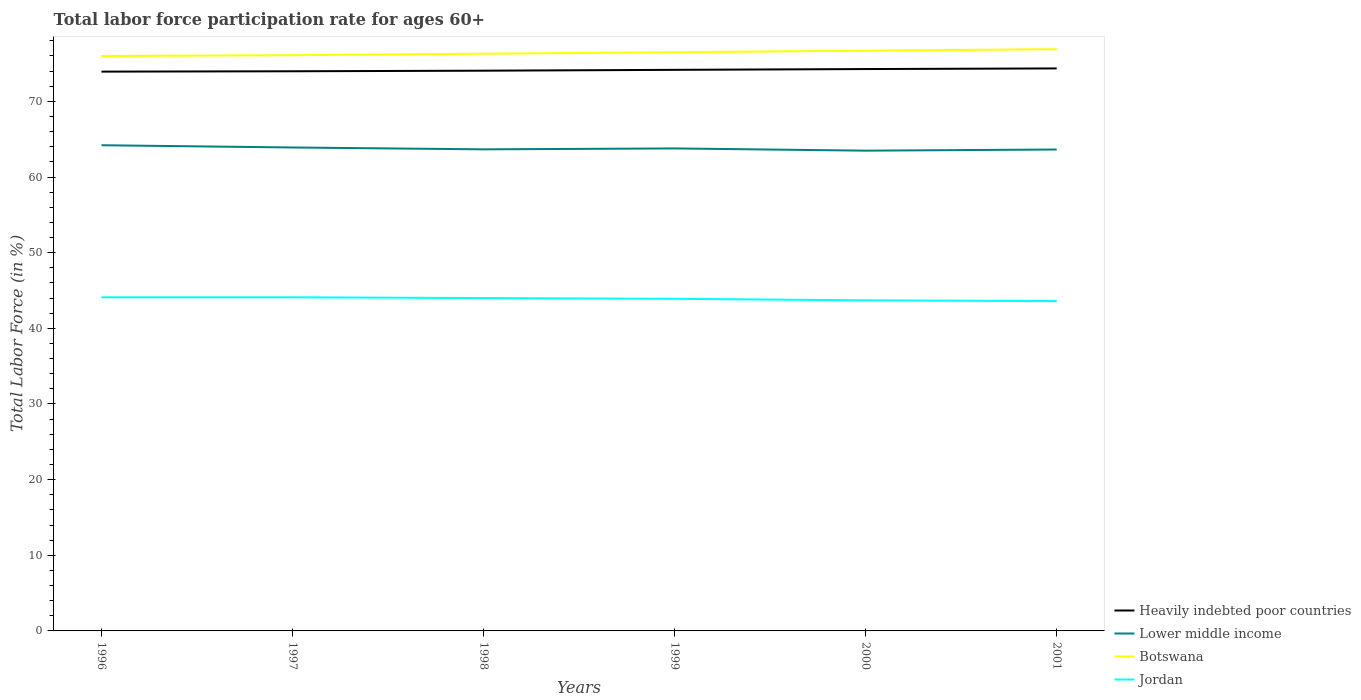How many different coloured lines are there?
Offer a terse response. 4. Across all years, what is the maximum labor force participation rate in Heavily indebted poor countries?
Offer a terse response. 73.93. In which year was the labor force participation rate in Botswana maximum?
Offer a very short reply. 1996. What is the total labor force participation rate in Lower middle income in the graph?
Ensure brevity in your answer.  0.25. How many lines are there?
Make the answer very short. 4. What is the difference between two consecutive major ticks on the Y-axis?
Your response must be concise. 10. Are the values on the major ticks of Y-axis written in scientific E-notation?
Provide a short and direct response. No. Does the graph contain grids?
Give a very brief answer. No. What is the title of the graph?
Your response must be concise. Total labor force participation rate for ages 60+. Does "Sub-Saharan Africa (all income levels)" appear as one of the legend labels in the graph?
Provide a succinct answer. No. What is the label or title of the Y-axis?
Provide a succinct answer. Total Labor Force (in %). What is the Total Labor Force (in %) in Heavily indebted poor countries in 1996?
Your answer should be very brief. 73.93. What is the Total Labor Force (in %) in Lower middle income in 1996?
Your response must be concise. 64.2. What is the Total Labor Force (in %) of Botswana in 1996?
Offer a terse response. 76. What is the Total Labor Force (in %) in Jordan in 1996?
Keep it short and to the point. 44.1. What is the Total Labor Force (in %) in Heavily indebted poor countries in 1997?
Provide a succinct answer. 73.98. What is the Total Labor Force (in %) of Lower middle income in 1997?
Your response must be concise. 63.9. What is the Total Labor Force (in %) of Botswana in 1997?
Ensure brevity in your answer.  76.1. What is the Total Labor Force (in %) in Jordan in 1997?
Ensure brevity in your answer.  44.1. What is the Total Labor Force (in %) of Heavily indebted poor countries in 1998?
Provide a short and direct response. 74.06. What is the Total Labor Force (in %) in Lower middle income in 1998?
Provide a short and direct response. 63.66. What is the Total Labor Force (in %) of Botswana in 1998?
Keep it short and to the point. 76.3. What is the Total Labor Force (in %) of Heavily indebted poor countries in 1999?
Provide a short and direct response. 74.17. What is the Total Labor Force (in %) in Lower middle income in 1999?
Your answer should be compact. 63.78. What is the Total Labor Force (in %) of Botswana in 1999?
Provide a short and direct response. 76.5. What is the Total Labor Force (in %) in Jordan in 1999?
Your answer should be very brief. 43.9. What is the Total Labor Force (in %) in Heavily indebted poor countries in 2000?
Offer a terse response. 74.27. What is the Total Labor Force (in %) of Lower middle income in 2000?
Provide a short and direct response. 63.49. What is the Total Labor Force (in %) in Botswana in 2000?
Provide a short and direct response. 76.7. What is the Total Labor Force (in %) in Jordan in 2000?
Provide a short and direct response. 43.7. What is the Total Labor Force (in %) in Heavily indebted poor countries in 2001?
Your response must be concise. 74.36. What is the Total Labor Force (in %) of Lower middle income in 2001?
Keep it short and to the point. 63.64. What is the Total Labor Force (in %) of Botswana in 2001?
Make the answer very short. 76.9. What is the Total Labor Force (in %) in Jordan in 2001?
Provide a succinct answer. 43.6. Across all years, what is the maximum Total Labor Force (in %) of Heavily indebted poor countries?
Offer a terse response. 74.36. Across all years, what is the maximum Total Labor Force (in %) of Lower middle income?
Your answer should be very brief. 64.2. Across all years, what is the maximum Total Labor Force (in %) of Botswana?
Give a very brief answer. 76.9. Across all years, what is the maximum Total Labor Force (in %) in Jordan?
Your answer should be compact. 44.1. Across all years, what is the minimum Total Labor Force (in %) of Heavily indebted poor countries?
Your answer should be very brief. 73.93. Across all years, what is the minimum Total Labor Force (in %) of Lower middle income?
Your response must be concise. 63.49. Across all years, what is the minimum Total Labor Force (in %) of Botswana?
Your answer should be very brief. 76. Across all years, what is the minimum Total Labor Force (in %) of Jordan?
Keep it short and to the point. 43.6. What is the total Total Labor Force (in %) of Heavily indebted poor countries in the graph?
Provide a short and direct response. 444.76. What is the total Total Labor Force (in %) in Lower middle income in the graph?
Offer a very short reply. 382.67. What is the total Total Labor Force (in %) of Botswana in the graph?
Provide a short and direct response. 458.5. What is the total Total Labor Force (in %) in Jordan in the graph?
Your answer should be compact. 263.4. What is the difference between the Total Labor Force (in %) in Heavily indebted poor countries in 1996 and that in 1997?
Give a very brief answer. -0.05. What is the difference between the Total Labor Force (in %) of Lower middle income in 1996 and that in 1997?
Give a very brief answer. 0.3. What is the difference between the Total Labor Force (in %) of Heavily indebted poor countries in 1996 and that in 1998?
Provide a short and direct response. -0.12. What is the difference between the Total Labor Force (in %) of Lower middle income in 1996 and that in 1998?
Keep it short and to the point. 0.55. What is the difference between the Total Labor Force (in %) in Botswana in 1996 and that in 1998?
Give a very brief answer. -0.3. What is the difference between the Total Labor Force (in %) of Jordan in 1996 and that in 1998?
Make the answer very short. 0.1. What is the difference between the Total Labor Force (in %) in Heavily indebted poor countries in 1996 and that in 1999?
Your answer should be very brief. -0.24. What is the difference between the Total Labor Force (in %) of Lower middle income in 1996 and that in 1999?
Make the answer very short. 0.42. What is the difference between the Total Labor Force (in %) of Jordan in 1996 and that in 1999?
Your answer should be very brief. 0.2. What is the difference between the Total Labor Force (in %) of Heavily indebted poor countries in 1996 and that in 2000?
Keep it short and to the point. -0.34. What is the difference between the Total Labor Force (in %) of Lower middle income in 1996 and that in 2000?
Offer a very short reply. 0.72. What is the difference between the Total Labor Force (in %) of Botswana in 1996 and that in 2000?
Your answer should be very brief. -0.7. What is the difference between the Total Labor Force (in %) in Heavily indebted poor countries in 1996 and that in 2001?
Provide a succinct answer. -0.43. What is the difference between the Total Labor Force (in %) of Lower middle income in 1996 and that in 2001?
Give a very brief answer. 0.57. What is the difference between the Total Labor Force (in %) in Botswana in 1996 and that in 2001?
Your answer should be compact. -0.9. What is the difference between the Total Labor Force (in %) of Jordan in 1996 and that in 2001?
Give a very brief answer. 0.5. What is the difference between the Total Labor Force (in %) of Heavily indebted poor countries in 1997 and that in 1998?
Ensure brevity in your answer.  -0.07. What is the difference between the Total Labor Force (in %) in Lower middle income in 1997 and that in 1998?
Your response must be concise. 0.25. What is the difference between the Total Labor Force (in %) of Botswana in 1997 and that in 1998?
Your response must be concise. -0.2. What is the difference between the Total Labor Force (in %) of Heavily indebted poor countries in 1997 and that in 1999?
Offer a very short reply. -0.19. What is the difference between the Total Labor Force (in %) of Lower middle income in 1997 and that in 1999?
Provide a succinct answer. 0.12. What is the difference between the Total Labor Force (in %) of Botswana in 1997 and that in 1999?
Provide a succinct answer. -0.4. What is the difference between the Total Labor Force (in %) in Heavily indebted poor countries in 1997 and that in 2000?
Your answer should be compact. -0.29. What is the difference between the Total Labor Force (in %) of Lower middle income in 1997 and that in 2000?
Provide a succinct answer. 0.42. What is the difference between the Total Labor Force (in %) in Botswana in 1997 and that in 2000?
Ensure brevity in your answer.  -0.6. What is the difference between the Total Labor Force (in %) of Jordan in 1997 and that in 2000?
Give a very brief answer. 0.4. What is the difference between the Total Labor Force (in %) of Heavily indebted poor countries in 1997 and that in 2001?
Ensure brevity in your answer.  -0.38. What is the difference between the Total Labor Force (in %) in Lower middle income in 1997 and that in 2001?
Your answer should be compact. 0.27. What is the difference between the Total Labor Force (in %) in Botswana in 1997 and that in 2001?
Give a very brief answer. -0.8. What is the difference between the Total Labor Force (in %) in Jordan in 1997 and that in 2001?
Offer a very short reply. 0.5. What is the difference between the Total Labor Force (in %) of Heavily indebted poor countries in 1998 and that in 1999?
Ensure brevity in your answer.  -0.11. What is the difference between the Total Labor Force (in %) in Lower middle income in 1998 and that in 1999?
Offer a terse response. -0.12. What is the difference between the Total Labor Force (in %) of Heavily indebted poor countries in 1998 and that in 2000?
Provide a succinct answer. -0.22. What is the difference between the Total Labor Force (in %) in Lower middle income in 1998 and that in 2000?
Offer a very short reply. 0.17. What is the difference between the Total Labor Force (in %) in Jordan in 1998 and that in 2000?
Make the answer very short. 0.3. What is the difference between the Total Labor Force (in %) of Heavily indebted poor countries in 1998 and that in 2001?
Your answer should be very brief. -0.3. What is the difference between the Total Labor Force (in %) in Lower middle income in 1998 and that in 2001?
Keep it short and to the point. 0.02. What is the difference between the Total Labor Force (in %) of Botswana in 1998 and that in 2001?
Your answer should be compact. -0.6. What is the difference between the Total Labor Force (in %) of Jordan in 1998 and that in 2001?
Ensure brevity in your answer.  0.4. What is the difference between the Total Labor Force (in %) in Heavily indebted poor countries in 1999 and that in 2000?
Your response must be concise. -0.11. What is the difference between the Total Labor Force (in %) of Lower middle income in 1999 and that in 2000?
Ensure brevity in your answer.  0.3. What is the difference between the Total Labor Force (in %) in Botswana in 1999 and that in 2000?
Your answer should be compact. -0.2. What is the difference between the Total Labor Force (in %) in Jordan in 1999 and that in 2000?
Provide a succinct answer. 0.2. What is the difference between the Total Labor Force (in %) of Heavily indebted poor countries in 1999 and that in 2001?
Your answer should be compact. -0.19. What is the difference between the Total Labor Force (in %) of Lower middle income in 1999 and that in 2001?
Make the answer very short. 0.14. What is the difference between the Total Labor Force (in %) of Jordan in 1999 and that in 2001?
Keep it short and to the point. 0.3. What is the difference between the Total Labor Force (in %) of Heavily indebted poor countries in 2000 and that in 2001?
Give a very brief answer. -0.08. What is the difference between the Total Labor Force (in %) in Lower middle income in 2000 and that in 2001?
Offer a very short reply. -0.15. What is the difference between the Total Labor Force (in %) of Botswana in 2000 and that in 2001?
Keep it short and to the point. -0.2. What is the difference between the Total Labor Force (in %) in Heavily indebted poor countries in 1996 and the Total Labor Force (in %) in Lower middle income in 1997?
Offer a terse response. 10.03. What is the difference between the Total Labor Force (in %) of Heavily indebted poor countries in 1996 and the Total Labor Force (in %) of Botswana in 1997?
Make the answer very short. -2.17. What is the difference between the Total Labor Force (in %) in Heavily indebted poor countries in 1996 and the Total Labor Force (in %) in Jordan in 1997?
Offer a very short reply. 29.83. What is the difference between the Total Labor Force (in %) of Lower middle income in 1996 and the Total Labor Force (in %) of Botswana in 1997?
Offer a very short reply. -11.9. What is the difference between the Total Labor Force (in %) of Lower middle income in 1996 and the Total Labor Force (in %) of Jordan in 1997?
Offer a terse response. 20.1. What is the difference between the Total Labor Force (in %) in Botswana in 1996 and the Total Labor Force (in %) in Jordan in 1997?
Provide a succinct answer. 31.9. What is the difference between the Total Labor Force (in %) of Heavily indebted poor countries in 1996 and the Total Labor Force (in %) of Lower middle income in 1998?
Keep it short and to the point. 10.27. What is the difference between the Total Labor Force (in %) of Heavily indebted poor countries in 1996 and the Total Labor Force (in %) of Botswana in 1998?
Ensure brevity in your answer.  -2.37. What is the difference between the Total Labor Force (in %) of Heavily indebted poor countries in 1996 and the Total Labor Force (in %) of Jordan in 1998?
Keep it short and to the point. 29.93. What is the difference between the Total Labor Force (in %) in Lower middle income in 1996 and the Total Labor Force (in %) in Botswana in 1998?
Give a very brief answer. -12.1. What is the difference between the Total Labor Force (in %) in Lower middle income in 1996 and the Total Labor Force (in %) in Jordan in 1998?
Give a very brief answer. 20.2. What is the difference between the Total Labor Force (in %) of Botswana in 1996 and the Total Labor Force (in %) of Jordan in 1998?
Provide a short and direct response. 32. What is the difference between the Total Labor Force (in %) in Heavily indebted poor countries in 1996 and the Total Labor Force (in %) in Lower middle income in 1999?
Provide a succinct answer. 10.15. What is the difference between the Total Labor Force (in %) of Heavily indebted poor countries in 1996 and the Total Labor Force (in %) of Botswana in 1999?
Keep it short and to the point. -2.57. What is the difference between the Total Labor Force (in %) in Heavily indebted poor countries in 1996 and the Total Labor Force (in %) in Jordan in 1999?
Ensure brevity in your answer.  30.03. What is the difference between the Total Labor Force (in %) in Lower middle income in 1996 and the Total Labor Force (in %) in Botswana in 1999?
Your answer should be very brief. -12.3. What is the difference between the Total Labor Force (in %) of Lower middle income in 1996 and the Total Labor Force (in %) of Jordan in 1999?
Your response must be concise. 20.3. What is the difference between the Total Labor Force (in %) of Botswana in 1996 and the Total Labor Force (in %) of Jordan in 1999?
Your answer should be compact. 32.1. What is the difference between the Total Labor Force (in %) in Heavily indebted poor countries in 1996 and the Total Labor Force (in %) in Lower middle income in 2000?
Offer a terse response. 10.45. What is the difference between the Total Labor Force (in %) of Heavily indebted poor countries in 1996 and the Total Labor Force (in %) of Botswana in 2000?
Offer a very short reply. -2.77. What is the difference between the Total Labor Force (in %) in Heavily indebted poor countries in 1996 and the Total Labor Force (in %) in Jordan in 2000?
Your response must be concise. 30.23. What is the difference between the Total Labor Force (in %) in Lower middle income in 1996 and the Total Labor Force (in %) in Botswana in 2000?
Your response must be concise. -12.5. What is the difference between the Total Labor Force (in %) in Lower middle income in 1996 and the Total Labor Force (in %) in Jordan in 2000?
Your answer should be compact. 20.5. What is the difference between the Total Labor Force (in %) in Botswana in 1996 and the Total Labor Force (in %) in Jordan in 2000?
Offer a terse response. 32.3. What is the difference between the Total Labor Force (in %) in Heavily indebted poor countries in 1996 and the Total Labor Force (in %) in Lower middle income in 2001?
Provide a succinct answer. 10.29. What is the difference between the Total Labor Force (in %) of Heavily indebted poor countries in 1996 and the Total Labor Force (in %) of Botswana in 2001?
Offer a terse response. -2.97. What is the difference between the Total Labor Force (in %) in Heavily indebted poor countries in 1996 and the Total Labor Force (in %) in Jordan in 2001?
Your answer should be very brief. 30.33. What is the difference between the Total Labor Force (in %) in Lower middle income in 1996 and the Total Labor Force (in %) in Botswana in 2001?
Offer a very short reply. -12.7. What is the difference between the Total Labor Force (in %) of Lower middle income in 1996 and the Total Labor Force (in %) of Jordan in 2001?
Your response must be concise. 20.6. What is the difference between the Total Labor Force (in %) of Botswana in 1996 and the Total Labor Force (in %) of Jordan in 2001?
Offer a very short reply. 32.4. What is the difference between the Total Labor Force (in %) of Heavily indebted poor countries in 1997 and the Total Labor Force (in %) of Lower middle income in 1998?
Your answer should be compact. 10.32. What is the difference between the Total Labor Force (in %) in Heavily indebted poor countries in 1997 and the Total Labor Force (in %) in Botswana in 1998?
Your response must be concise. -2.32. What is the difference between the Total Labor Force (in %) of Heavily indebted poor countries in 1997 and the Total Labor Force (in %) of Jordan in 1998?
Your answer should be very brief. 29.98. What is the difference between the Total Labor Force (in %) in Lower middle income in 1997 and the Total Labor Force (in %) in Botswana in 1998?
Offer a very short reply. -12.4. What is the difference between the Total Labor Force (in %) in Lower middle income in 1997 and the Total Labor Force (in %) in Jordan in 1998?
Ensure brevity in your answer.  19.9. What is the difference between the Total Labor Force (in %) of Botswana in 1997 and the Total Labor Force (in %) of Jordan in 1998?
Your answer should be compact. 32.1. What is the difference between the Total Labor Force (in %) of Heavily indebted poor countries in 1997 and the Total Labor Force (in %) of Lower middle income in 1999?
Offer a terse response. 10.2. What is the difference between the Total Labor Force (in %) of Heavily indebted poor countries in 1997 and the Total Labor Force (in %) of Botswana in 1999?
Provide a succinct answer. -2.52. What is the difference between the Total Labor Force (in %) in Heavily indebted poor countries in 1997 and the Total Labor Force (in %) in Jordan in 1999?
Ensure brevity in your answer.  30.08. What is the difference between the Total Labor Force (in %) in Lower middle income in 1997 and the Total Labor Force (in %) in Botswana in 1999?
Give a very brief answer. -12.6. What is the difference between the Total Labor Force (in %) of Lower middle income in 1997 and the Total Labor Force (in %) of Jordan in 1999?
Make the answer very short. 20. What is the difference between the Total Labor Force (in %) in Botswana in 1997 and the Total Labor Force (in %) in Jordan in 1999?
Make the answer very short. 32.2. What is the difference between the Total Labor Force (in %) of Heavily indebted poor countries in 1997 and the Total Labor Force (in %) of Lower middle income in 2000?
Your response must be concise. 10.49. What is the difference between the Total Labor Force (in %) in Heavily indebted poor countries in 1997 and the Total Labor Force (in %) in Botswana in 2000?
Ensure brevity in your answer.  -2.72. What is the difference between the Total Labor Force (in %) in Heavily indebted poor countries in 1997 and the Total Labor Force (in %) in Jordan in 2000?
Your answer should be very brief. 30.28. What is the difference between the Total Labor Force (in %) in Lower middle income in 1997 and the Total Labor Force (in %) in Botswana in 2000?
Offer a terse response. -12.8. What is the difference between the Total Labor Force (in %) in Lower middle income in 1997 and the Total Labor Force (in %) in Jordan in 2000?
Keep it short and to the point. 20.2. What is the difference between the Total Labor Force (in %) of Botswana in 1997 and the Total Labor Force (in %) of Jordan in 2000?
Your answer should be compact. 32.4. What is the difference between the Total Labor Force (in %) of Heavily indebted poor countries in 1997 and the Total Labor Force (in %) of Lower middle income in 2001?
Keep it short and to the point. 10.34. What is the difference between the Total Labor Force (in %) in Heavily indebted poor countries in 1997 and the Total Labor Force (in %) in Botswana in 2001?
Make the answer very short. -2.92. What is the difference between the Total Labor Force (in %) of Heavily indebted poor countries in 1997 and the Total Labor Force (in %) of Jordan in 2001?
Give a very brief answer. 30.38. What is the difference between the Total Labor Force (in %) in Lower middle income in 1997 and the Total Labor Force (in %) in Botswana in 2001?
Ensure brevity in your answer.  -13. What is the difference between the Total Labor Force (in %) of Lower middle income in 1997 and the Total Labor Force (in %) of Jordan in 2001?
Provide a short and direct response. 20.3. What is the difference between the Total Labor Force (in %) in Botswana in 1997 and the Total Labor Force (in %) in Jordan in 2001?
Keep it short and to the point. 32.5. What is the difference between the Total Labor Force (in %) in Heavily indebted poor countries in 1998 and the Total Labor Force (in %) in Lower middle income in 1999?
Give a very brief answer. 10.27. What is the difference between the Total Labor Force (in %) of Heavily indebted poor countries in 1998 and the Total Labor Force (in %) of Botswana in 1999?
Your answer should be compact. -2.44. What is the difference between the Total Labor Force (in %) of Heavily indebted poor countries in 1998 and the Total Labor Force (in %) of Jordan in 1999?
Give a very brief answer. 30.16. What is the difference between the Total Labor Force (in %) in Lower middle income in 1998 and the Total Labor Force (in %) in Botswana in 1999?
Your response must be concise. -12.84. What is the difference between the Total Labor Force (in %) of Lower middle income in 1998 and the Total Labor Force (in %) of Jordan in 1999?
Your answer should be very brief. 19.76. What is the difference between the Total Labor Force (in %) in Botswana in 1998 and the Total Labor Force (in %) in Jordan in 1999?
Make the answer very short. 32.4. What is the difference between the Total Labor Force (in %) in Heavily indebted poor countries in 1998 and the Total Labor Force (in %) in Lower middle income in 2000?
Make the answer very short. 10.57. What is the difference between the Total Labor Force (in %) of Heavily indebted poor countries in 1998 and the Total Labor Force (in %) of Botswana in 2000?
Provide a succinct answer. -2.64. What is the difference between the Total Labor Force (in %) in Heavily indebted poor countries in 1998 and the Total Labor Force (in %) in Jordan in 2000?
Your answer should be very brief. 30.36. What is the difference between the Total Labor Force (in %) in Lower middle income in 1998 and the Total Labor Force (in %) in Botswana in 2000?
Provide a short and direct response. -13.04. What is the difference between the Total Labor Force (in %) of Lower middle income in 1998 and the Total Labor Force (in %) of Jordan in 2000?
Offer a terse response. 19.96. What is the difference between the Total Labor Force (in %) of Botswana in 1998 and the Total Labor Force (in %) of Jordan in 2000?
Your answer should be very brief. 32.6. What is the difference between the Total Labor Force (in %) of Heavily indebted poor countries in 1998 and the Total Labor Force (in %) of Lower middle income in 2001?
Your response must be concise. 10.42. What is the difference between the Total Labor Force (in %) of Heavily indebted poor countries in 1998 and the Total Labor Force (in %) of Botswana in 2001?
Give a very brief answer. -2.84. What is the difference between the Total Labor Force (in %) of Heavily indebted poor countries in 1998 and the Total Labor Force (in %) of Jordan in 2001?
Provide a short and direct response. 30.46. What is the difference between the Total Labor Force (in %) of Lower middle income in 1998 and the Total Labor Force (in %) of Botswana in 2001?
Keep it short and to the point. -13.24. What is the difference between the Total Labor Force (in %) of Lower middle income in 1998 and the Total Labor Force (in %) of Jordan in 2001?
Keep it short and to the point. 20.06. What is the difference between the Total Labor Force (in %) in Botswana in 1998 and the Total Labor Force (in %) in Jordan in 2001?
Your answer should be compact. 32.7. What is the difference between the Total Labor Force (in %) in Heavily indebted poor countries in 1999 and the Total Labor Force (in %) in Lower middle income in 2000?
Give a very brief answer. 10.68. What is the difference between the Total Labor Force (in %) of Heavily indebted poor countries in 1999 and the Total Labor Force (in %) of Botswana in 2000?
Your answer should be very brief. -2.53. What is the difference between the Total Labor Force (in %) in Heavily indebted poor countries in 1999 and the Total Labor Force (in %) in Jordan in 2000?
Keep it short and to the point. 30.47. What is the difference between the Total Labor Force (in %) in Lower middle income in 1999 and the Total Labor Force (in %) in Botswana in 2000?
Make the answer very short. -12.92. What is the difference between the Total Labor Force (in %) of Lower middle income in 1999 and the Total Labor Force (in %) of Jordan in 2000?
Give a very brief answer. 20.08. What is the difference between the Total Labor Force (in %) in Botswana in 1999 and the Total Labor Force (in %) in Jordan in 2000?
Your response must be concise. 32.8. What is the difference between the Total Labor Force (in %) in Heavily indebted poor countries in 1999 and the Total Labor Force (in %) in Lower middle income in 2001?
Offer a terse response. 10.53. What is the difference between the Total Labor Force (in %) of Heavily indebted poor countries in 1999 and the Total Labor Force (in %) of Botswana in 2001?
Offer a terse response. -2.73. What is the difference between the Total Labor Force (in %) of Heavily indebted poor countries in 1999 and the Total Labor Force (in %) of Jordan in 2001?
Offer a terse response. 30.57. What is the difference between the Total Labor Force (in %) in Lower middle income in 1999 and the Total Labor Force (in %) in Botswana in 2001?
Ensure brevity in your answer.  -13.12. What is the difference between the Total Labor Force (in %) of Lower middle income in 1999 and the Total Labor Force (in %) of Jordan in 2001?
Keep it short and to the point. 20.18. What is the difference between the Total Labor Force (in %) in Botswana in 1999 and the Total Labor Force (in %) in Jordan in 2001?
Provide a succinct answer. 32.9. What is the difference between the Total Labor Force (in %) of Heavily indebted poor countries in 2000 and the Total Labor Force (in %) of Lower middle income in 2001?
Ensure brevity in your answer.  10.64. What is the difference between the Total Labor Force (in %) of Heavily indebted poor countries in 2000 and the Total Labor Force (in %) of Botswana in 2001?
Your answer should be very brief. -2.63. What is the difference between the Total Labor Force (in %) of Heavily indebted poor countries in 2000 and the Total Labor Force (in %) of Jordan in 2001?
Your response must be concise. 30.67. What is the difference between the Total Labor Force (in %) in Lower middle income in 2000 and the Total Labor Force (in %) in Botswana in 2001?
Provide a short and direct response. -13.41. What is the difference between the Total Labor Force (in %) of Lower middle income in 2000 and the Total Labor Force (in %) of Jordan in 2001?
Offer a very short reply. 19.89. What is the difference between the Total Labor Force (in %) in Botswana in 2000 and the Total Labor Force (in %) in Jordan in 2001?
Offer a very short reply. 33.1. What is the average Total Labor Force (in %) in Heavily indebted poor countries per year?
Your response must be concise. 74.13. What is the average Total Labor Force (in %) in Lower middle income per year?
Give a very brief answer. 63.78. What is the average Total Labor Force (in %) in Botswana per year?
Ensure brevity in your answer.  76.42. What is the average Total Labor Force (in %) in Jordan per year?
Provide a succinct answer. 43.9. In the year 1996, what is the difference between the Total Labor Force (in %) of Heavily indebted poor countries and Total Labor Force (in %) of Lower middle income?
Give a very brief answer. 9.73. In the year 1996, what is the difference between the Total Labor Force (in %) in Heavily indebted poor countries and Total Labor Force (in %) in Botswana?
Provide a succinct answer. -2.07. In the year 1996, what is the difference between the Total Labor Force (in %) in Heavily indebted poor countries and Total Labor Force (in %) in Jordan?
Offer a very short reply. 29.83. In the year 1996, what is the difference between the Total Labor Force (in %) of Lower middle income and Total Labor Force (in %) of Botswana?
Provide a succinct answer. -11.8. In the year 1996, what is the difference between the Total Labor Force (in %) in Lower middle income and Total Labor Force (in %) in Jordan?
Your response must be concise. 20.1. In the year 1996, what is the difference between the Total Labor Force (in %) in Botswana and Total Labor Force (in %) in Jordan?
Ensure brevity in your answer.  31.9. In the year 1997, what is the difference between the Total Labor Force (in %) in Heavily indebted poor countries and Total Labor Force (in %) in Lower middle income?
Your answer should be very brief. 10.08. In the year 1997, what is the difference between the Total Labor Force (in %) in Heavily indebted poor countries and Total Labor Force (in %) in Botswana?
Give a very brief answer. -2.12. In the year 1997, what is the difference between the Total Labor Force (in %) in Heavily indebted poor countries and Total Labor Force (in %) in Jordan?
Make the answer very short. 29.88. In the year 1997, what is the difference between the Total Labor Force (in %) of Lower middle income and Total Labor Force (in %) of Botswana?
Your response must be concise. -12.2. In the year 1997, what is the difference between the Total Labor Force (in %) of Lower middle income and Total Labor Force (in %) of Jordan?
Keep it short and to the point. 19.8. In the year 1998, what is the difference between the Total Labor Force (in %) of Heavily indebted poor countries and Total Labor Force (in %) of Lower middle income?
Your answer should be very brief. 10.4. In the year 1998, what is the difference between the Total Labor Force (in %) of Heavily indebted poor countries and Total Labor Force (in %) of Botswana?
Offer a terse response. -2.24. In the year 1998, what is the difference between the Total Labor Force (in %) of Heavily indebted poor countries and Total Labor Force (in %) of Jordan?
Provide a succinct answer. 30.06. In the year 1998, what is the difference between the Total Labor Force (in %) of Lower middle income and Total Labor Force (in %) of Botswana?
Your response must be concise. -12.64. In the year 1998, what is the difference between the Total Labor Force (in %) in Lower middle income and Total Labor Force (in %) in Jordan?
Your answer should be compact. 19.66. In the year 1998, what is the difference between the Total Labor Force (in %) of Botswana and Total Labor Force (in %) of Jordan?
Provide a succinct answer. 32.3. In the year 1999, what is the difference between the Total Labor Force (in %) in Heavily indebted poor countries and Total Labor Force (in %) in Lower middle income?
Offer a terse response. 10.39. In the year 1999, what is the difference between the Total Labor Force (in %) in Heavily indebted poor countries and Total Labor Force (in %) in Botswana?
Your response must be concise. -2.33. In the year 1999, what is the difference between the Total Labor Force (in %) of Heavily indebted poor countries and Total Labor Force (in %) of Jordan?
Your answer should be compact. 30.27. In the year 1999, what is the difference between the Total Labor Force (in %) of Lower middle income and Total Labor Force (in %) of Botswana?
Give a very brief answer. -12.72. In the year 1999, what is the difference between the Total Labor Force (in %) of Lower middle income and Total Labor Force (in %) of Jordan?
Provide a short and direct response. 19.88. In the year 1999, what is the difference between the Total Labor Force (in %) of Botswana and Total Labor Force (in %) of Jordan?
Offer a terse response. 32.6. In the year 2000, what is the difference between the Total Labor Force (in %) in Heavily indebted poor countries and Total Labor Force (in %) in Lower middle income?
Your answer should be compact. 10.79. In the year 2000, what is the difference between the Total Labor Force (in %) in Heavily indebted poor countries and Total Labor Force (in %) in Botswana?
Ensure brevity in your answer.  -2.43. In the year 2000, what is the difference between the Total Labor Force (in %) of Heavily indebted poor countries and Total Labor Force (in %) of Jordan?
Ensure brevity in your answer.  30.57. In the year 2000, what is the difference between the Total Labor Force (in %) of Lower middle income and Total Labor Force (in %) of Botswana?
Provide a succinct answer. -13.21. In the year 2000, what is the difference between the Total Labor Force (in %) of Lower middle income and Total Labor Force (in %) of Jordan?
Provide a short and direct response. 19.79. In the year 2001, what is the difference between the Total Labor Force (in %) in Heavily indebted poor countries and Total Labor Force (in %) in Lower middle income?
Offer a very short reply. 10.72. In the year 2001, what is the difference between the Total Labor Force (in %) in Heavily indebted poor countries and Total Labor Force (in %) in Botswana?
Give a very brief answer. -2.54. In the year 2001, what is the difference between the Total Labor Force (in %) in Heavily indebted poor countries and Total Labor Force (in %) in Jordan?
Your answer should be compact. 30.76. In the year 2001, what is the difference between the Total Labor Force (in %) in Lower middle income and Total Labor Force (in %) in Botswana?
Offer a very short reply. -13.26. In the year 2001, what is the difference between the Total Labor Force (in %) of Lower middle income and Total Labor Force (in %) of Jordan?
Provide a succinct answer. 20.04. In the year 2001, what is the difference between the Total Labor Force (in %) in Botswana and Total Labor Force (in %) in Jordan?
Your answer should be very brief. 33.3. What is the ratio of the Total Labor Force (in %) in Botswana in 1996 to that in 1997?
Provide a succinct answer. 1. What is the ratio of the Total Labor Force (in %) in Heavily indebted poor countries in 1996 to that in 1998?
Offer a terse response. 1. What is the ratio of the Total Labor Force (in %) of Lower middle income in 1996 to that in 1998?
Make the answer very short. 1.01. What is the ratio of the Total Labor Force (in %) of Jordan in 1996 to that in 1998?
Provide a succinct answer. 1. What is the ratio of the Total Labor Force (in %) in Heavily indebted poor countries in 1996 to that in 1999?
Offer a very short reply. 1. What is the ratio of the Total Labor Force (in %) in Lower middle income in 1996 to that in 1999?
Your answer should be very brief. 1.01. What is the ratio of the Total Labor Force (in %) in Heavily indebted poor countries in 1996 to that in 2000?
Your answer should be compact. 1. What is the ratio of the Total Labor Force (in %) of Lower middle income in 1996 to that in 2000?
Provide a short and direct response. 1.01. What is the ratio of the Total Labor Force (in %) in Botswana in 1996 to that in 2000?
Offer a terse response. 0.99. What is the ratio of the Total Labor Force (in %) of Jordan in 1996 to that in 2000?
Provide a succinct answer. 1.01. What is the ratio of the Total Labor Force (in %) in Lower middle income in 1996 to that in 2001?
Your answer should be compact. 1.01. What is the ratio of the Total Labor Force (in %) of Botswana in 1996 to that in 2001?
Ensure brevity in your answer.  0.99. What is the ratio of the Total Labor Force (in %) of Jordan in 1996 to that in 2001?
Ensure brevity in your answer.  1.01. What is the ratio of the Total Labor Force (in %) in Heavily indebted poor countries in 1997 to that in 1999?
Give a very brief answer. 1. What is the ratio of the Total Labor Force (in %) in Botswana in 1997 to that in 1999?
Provide a succinct answer. 0.99. What is the ratio of the Total Labor Force (in %) in Lower middle income in 1997 to that in 2000?
Ensure brevity in your answer.  1.01. What is the ratio of the Total Labor Force (in %) in Jordan in 1997 to that in 2000?
Provide a succinct answer. 1.01. What is the ratio of the Total Labor Force (in %) in Heavily indebted poor countries in 1997 to that in 2001?
Your answer should be very brief. 0.99. What is the ratio of the Total Labor Force (in %) in Botswana in 1997 to that in 2001?
Ensure brevity in your answer.  0.99. What is the ratio of the Total Labor Force (in %) in Jordan in 1997 to that in 2001?
Ensure brevity in your answer.  1.01. What is the ratio of the Total Labor Force (in %) of Lower middle income in 1998 to that in 1999?
Keep it short and to the point. 1. What is the ratio of the Total Labor Force (in %) of Botswana in 1998 to that in 1999?
Make the answer very short. 1. What is the ratio of the Total Labor Force (in %) in Jordan in 1998 to that in 1999?
Your answer should be compact. 1. What is the ratio of the Total Labor Force (in %) in Lower middle income in 1998 to that in 2000?
Ensure brevity in your answer.  1. What is the ratio of the Total Labor Force (in %) in Botswana in 1998 to that in 2000?
Your response must be concise. 0.99. What is the ratio of the Total Labor Force (in %) in Jordan in 1998 to that in 2000?
Keep it short and to the point. 1.01. What is the ratio of the Total Labor Force (in %) in Heavily indebted poor countries in 1998 to that in 2001?
Offer a very short reply. 1. What is the ratio of the Total Labor Force (in %) of Lower middle income in 1998 to that in 2001?
Offer a very short reply. 1. What is the ratio of the Total Labor Force (in %) in Jordan in 1998 to that in 2001?
Give a very brief answer. 1.01. What is the ratio of the Total Labor Force (in %) of Lower middle income in 1999 to that in 2000?
Your response must be concise. 1. What is the ratio of the Total Labor Force (in %) in Botswana in 1999 to that in 2000?
Give a very brief answer. 1. What is the ratio of the Total Labor Force (in %) of Jordan in 1999 to that in 2000?
Provide a succinct answer. 1. What is the ratio of the Total Labor Force (in %) in Heavily indebted poor countries in 1999 to that in 2001?
Your answer should be very brief. 1. What is the ratio of the Total Labor Force (in %) in Lower middle income in 1999 to that in 2001?
Your answer should be compact. 1. What is the ratio of the Total Labor Force (in %) of Botswana in 1999 to that in 2001?
Give a very brief answer. 0.99. What is the ratio of the Total Labor Force (in %) in Botswana in 2000 to that in 2001?
Offer a very short reply. 1. What is the difference between the highest and the second highest Total Labor Force (in %) in Heavily indebted poor countries?
Offer a terse response. 0.08. What is the difference between the highest and the second highest Total Labor Force (in %) in Lower middle income?
Make the answer very short. 0.3. What is the difference between the highest and the second highest Total Labor Force (in %) in Botswana?
Give a very brief answer. 0.2. What is the difference between the highest and the lowest Total Labor Force (in %) in Heavily indebted poor countries?
Keep it short and to the point. 0.43. What is the difference between the highest and the lowest Total Labor Force (in %) of Lower middle income?
Ensure brevity in your answer.  0.72. 